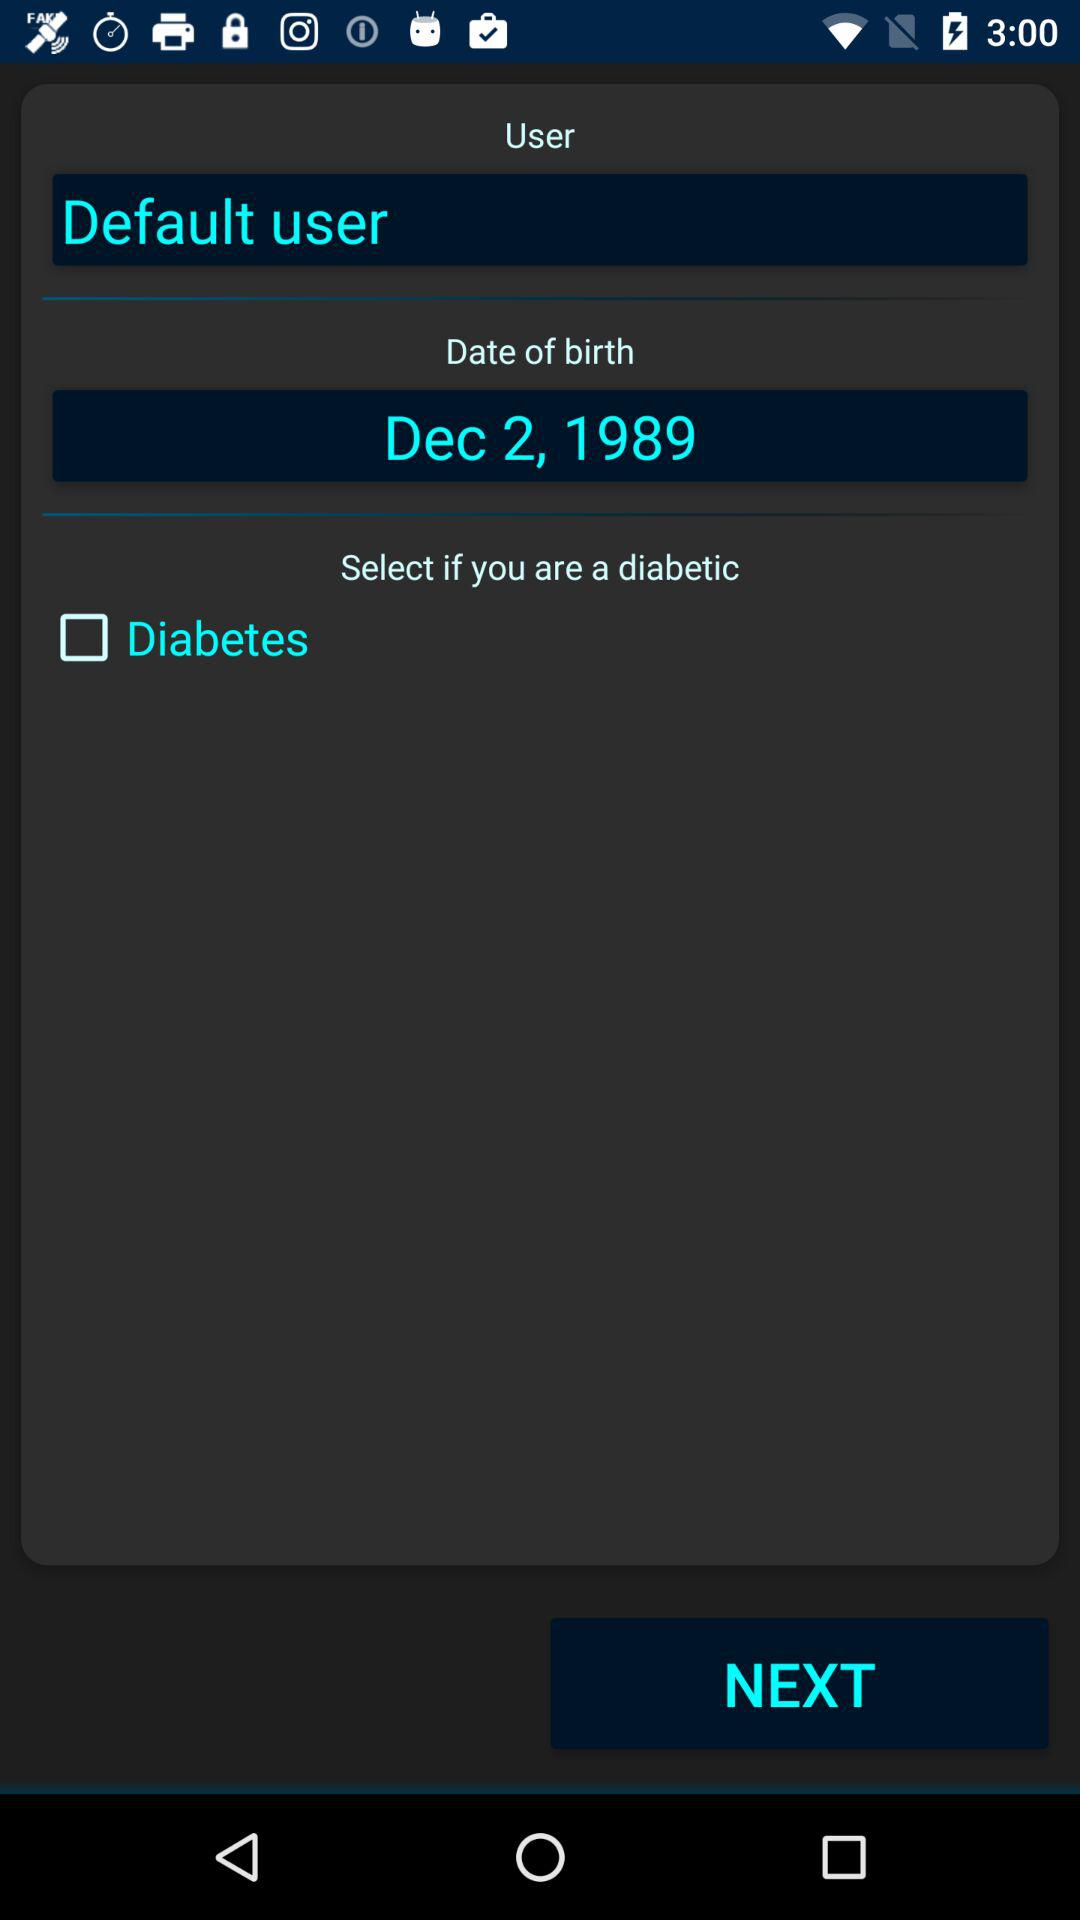What's the birth date? The birth date is December 2, 1989. 